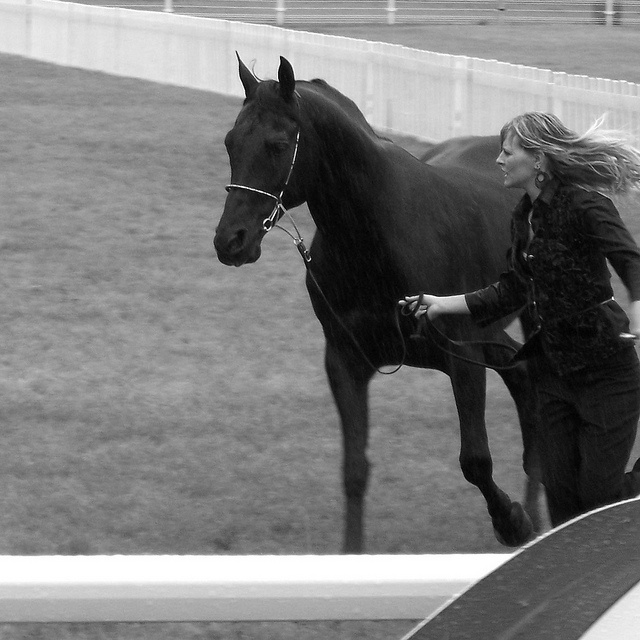Describe the objects in this image and their specific colors. I can see horse in white, black, gray, and lightgray tones and people in white, black, gray, darkgray, and lightgray tones in this image. 